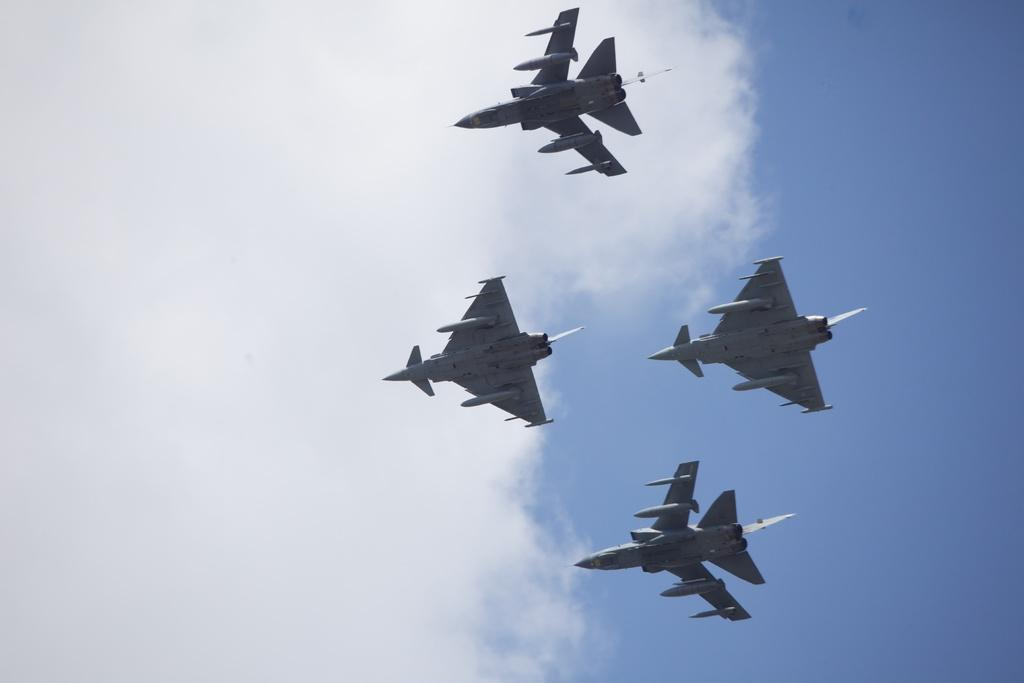What is the main subject of the image? The main subject of the image is airplanes. What are the airplanes doing in the image? The airplanes are flying in the sky. What grade is the airplane in the image? Airplanes are not graded, as they are machines and not students. 